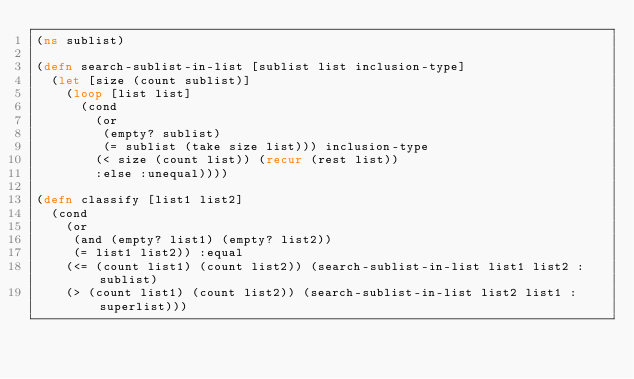<code> <loc_0><loc_0><loc_500><loc_500><_Clojure_>(ns sublist)

(defn search-sublist-in-list [sublist list inclusion-type]
  (let [size (count sublist)]
    (loop [list list]
      (cond
        (or
         (empty? sublist)
         (= sublist (take size list))) inclusion-type
        (< size (count list)) (recur (rest list))
        :else :unequal))))

(defn classify [list1 list2]
  (cond
    (or
     (and (empty? list1) (empty? list2))
     (= list1 list2)) :equal
    (<= (count list1) (count list2)) (search-sublist-in-list list1 list2 :sublist)
    (> (count list1) (count list2)) (search-sublist-in-list list2 list1 :superlist)))
</code> 